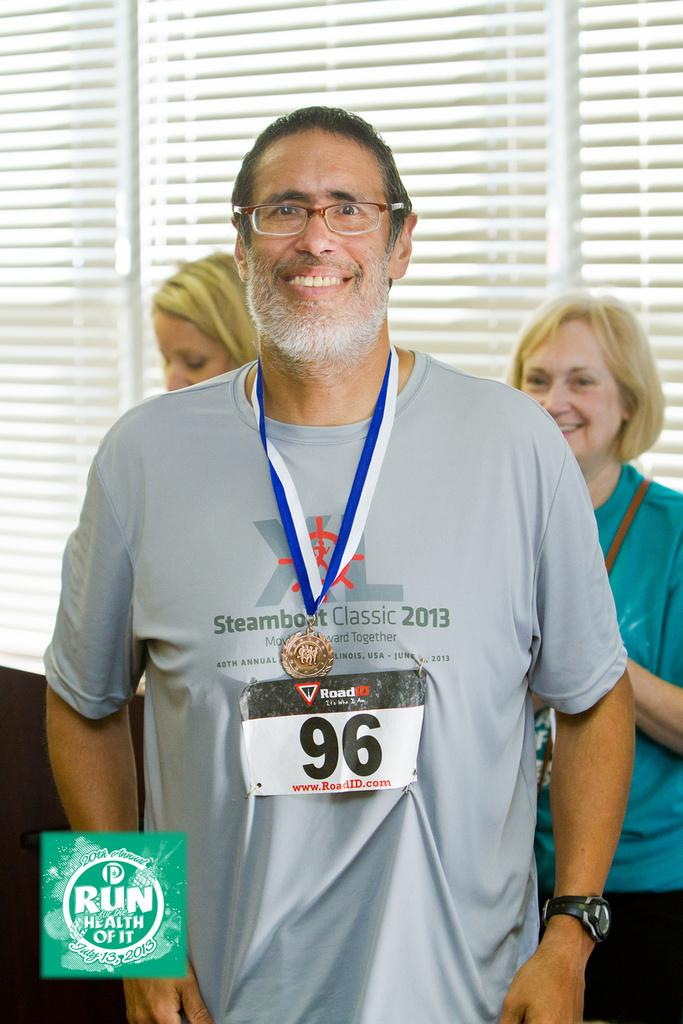<image>
Present a compact description of the photo's key features. a person with the number 96 on their shirt 